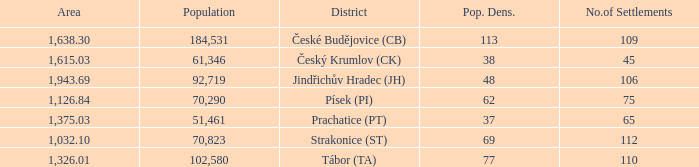What is the lowest population density of Strakonice (st) with more than 112 settlements? None. 